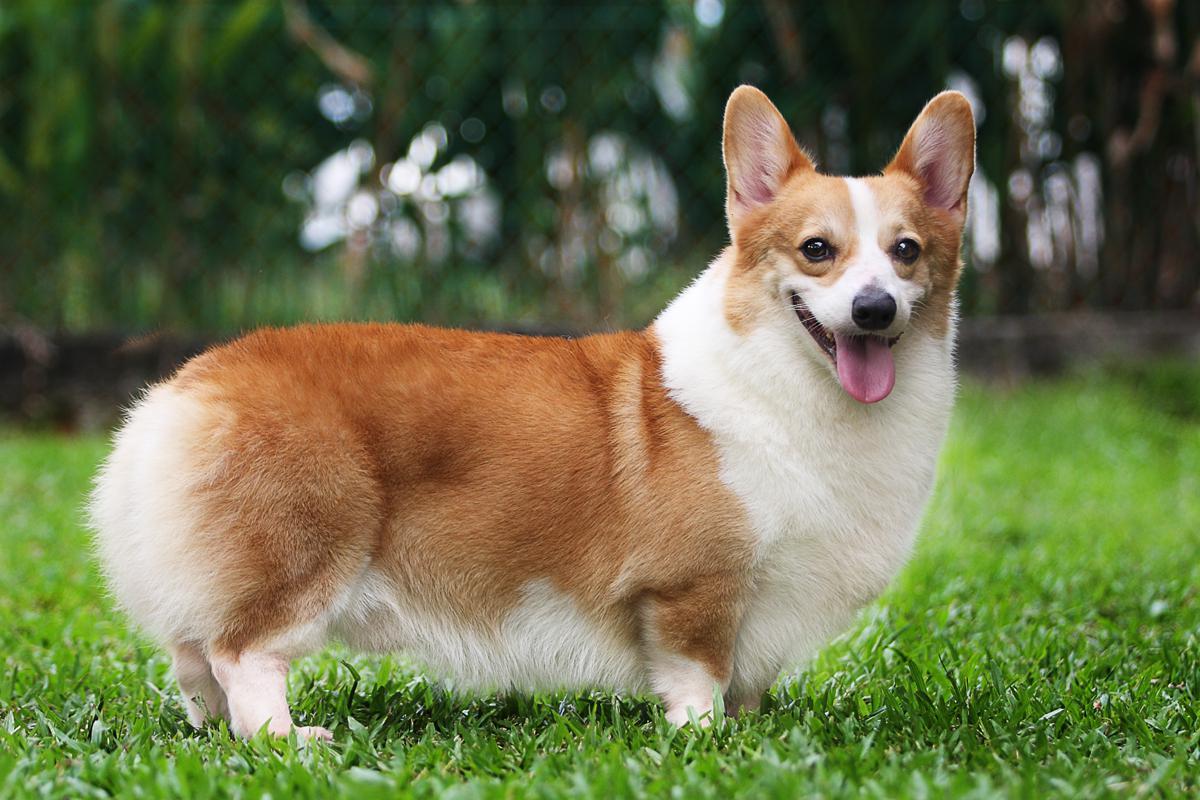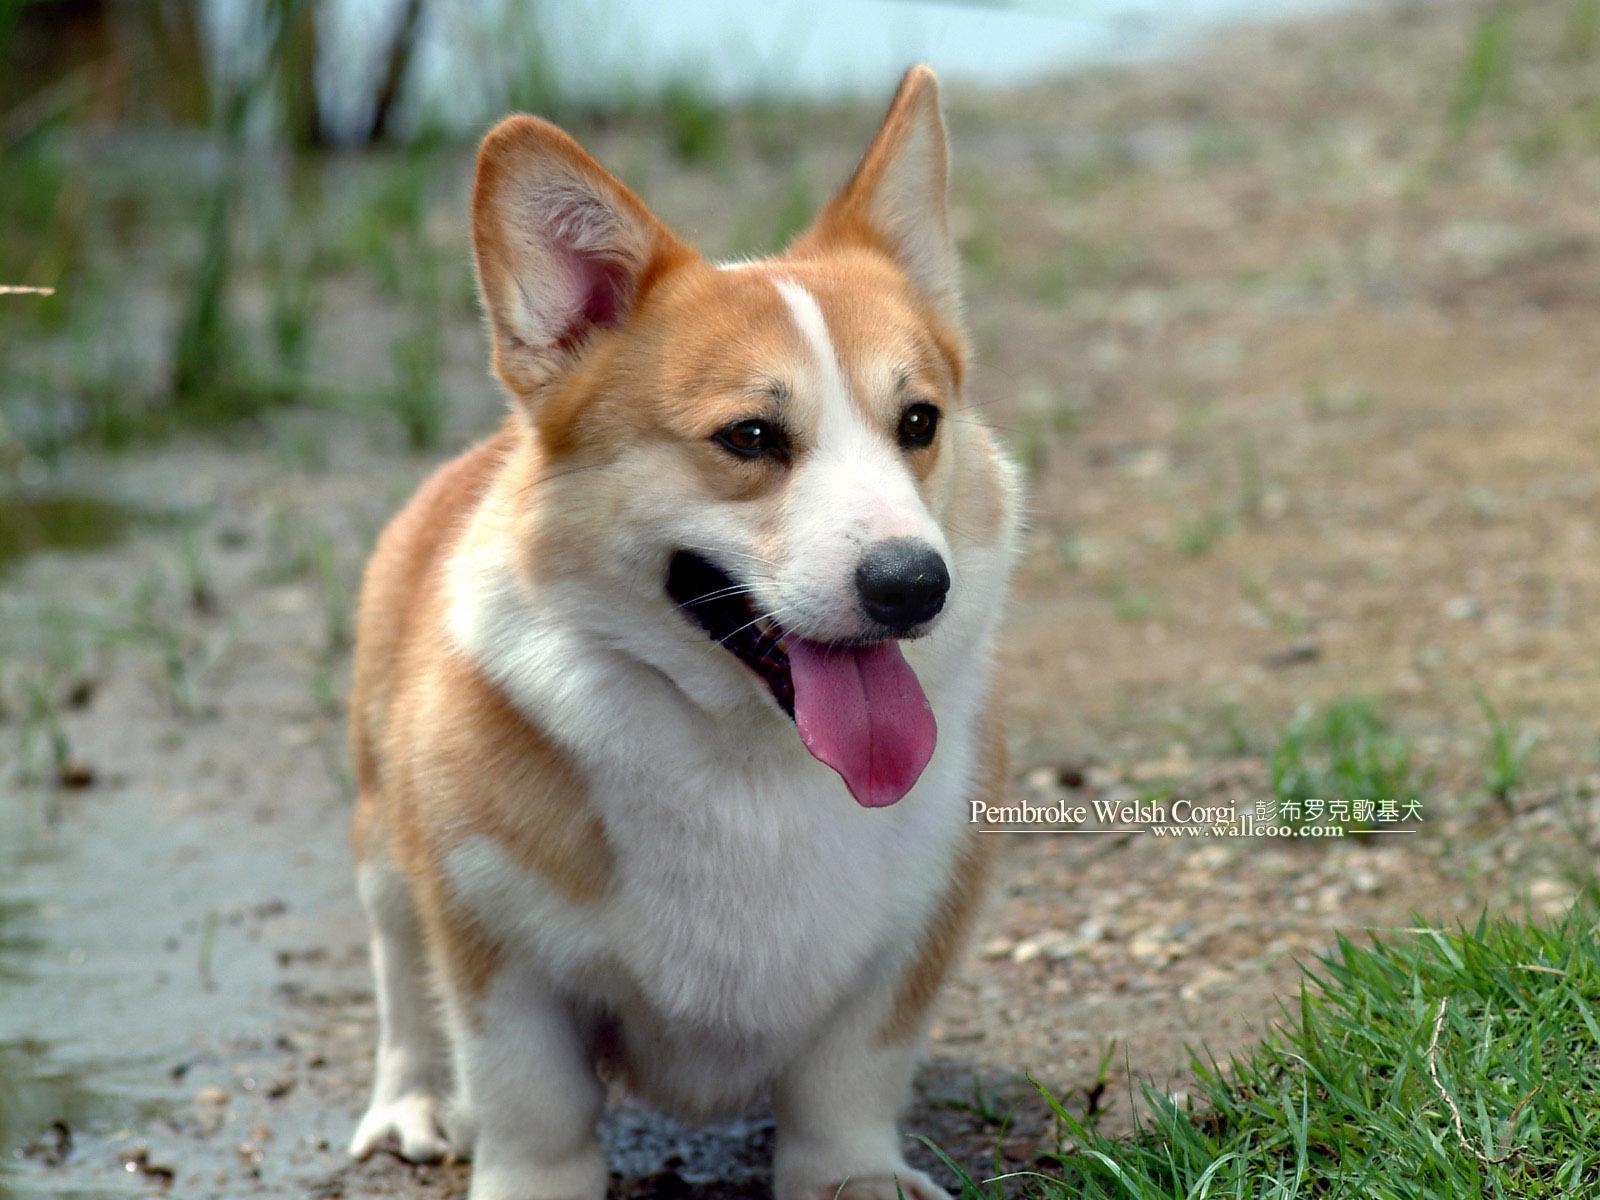The first image is the image on the left, the second image is the image on the right. Analyze the images presented: Is the assertion "Both images in the pair include two corgis next to each other." valid? Answer yes or no. No. The first image is the image on the left, the second image is the image on the right. For the images shown, is this caption "There are two puppies with ears pointing up as they run right together on grass." true? Answer yes or no. No. 